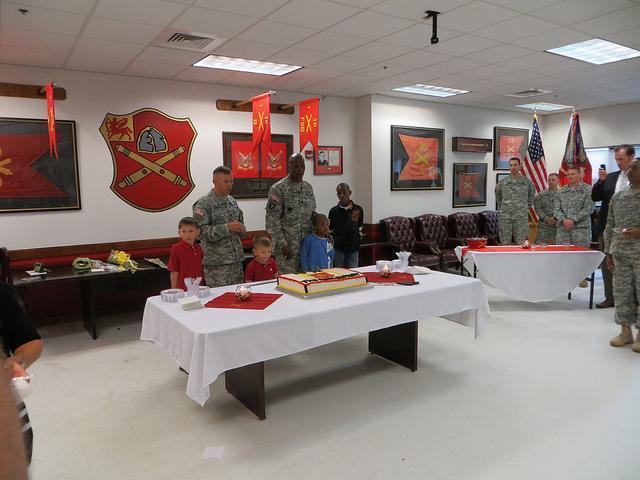How many people are there?
Give a very brief answer. 8. How many dining tables are there?
Give a very brief answer. 2. How many boat on the seasore?
Give a very brief answer. 0. 